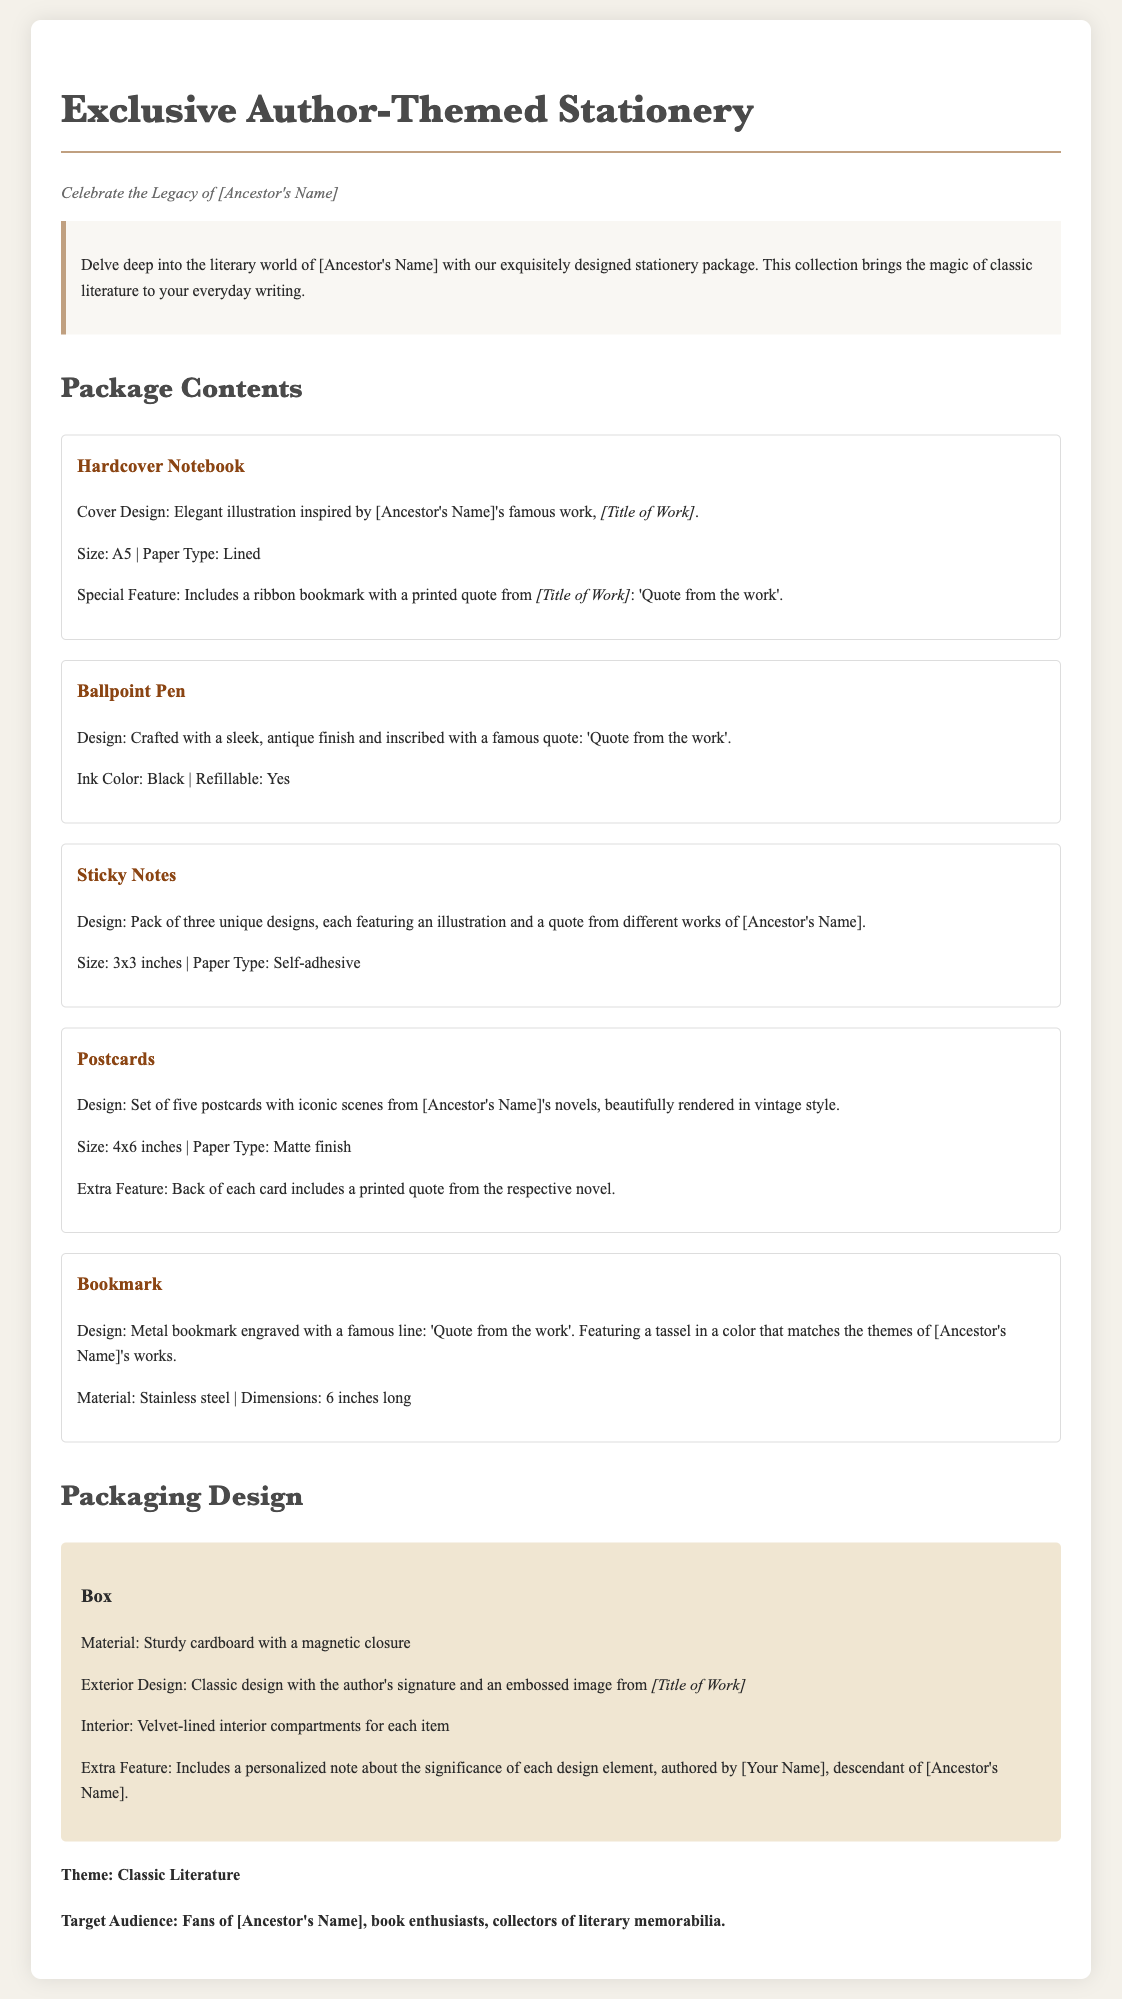what is the title of the document? The title of the document is prominently displayed at the top of the page.
Answer: Exclusive Author-Themed Stationery who is the theme of the stationery package based on? The subtitle indicates that the stationery celebrates the legacy of the author related to the product.
Answer: [Ancestor's Name] how many unique designs are included in the sticky notes? The description of the sticky notes specifies the quantity of designs available.
Answer: three what is the size of the hardcover notebook? The size of the hardcover notebook is mentioned in the description of that component.
Answer: A5 which material is the bookmark made of? The material used for the bookmark is explicitly stated in its description.
Answer: Stainless steel what special feature does the box have? The box description includes a notable aspect that enhances its appeal.
Answer: magnetic closure who authored the personalized note included in the packaging? The packaging design section reveals who wrote the personalized note about the designs.
Answer: [Your Name] what is the target audience for this stationery package? The target audience is outlined towards the end of the document.
Answer: Fans of [Ancestor's Name] 